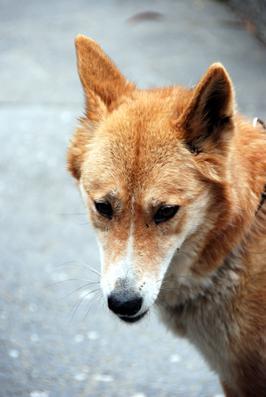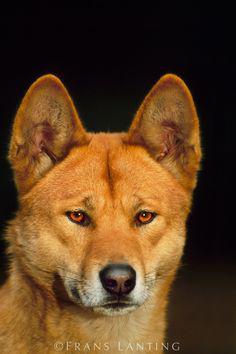The first image is the image on the left, the second image is the image on the right. Given the left and right images, does the statement "In at least one of the images, there is a large body of water in the background." hold true? Answer yes or no. No. The first image is the image on the left, the second image is the image on the right. Assess this claim about the two images: "At least one of the dogs is in front of a large body of water.". Correct or not? Answer yes or no. No. 